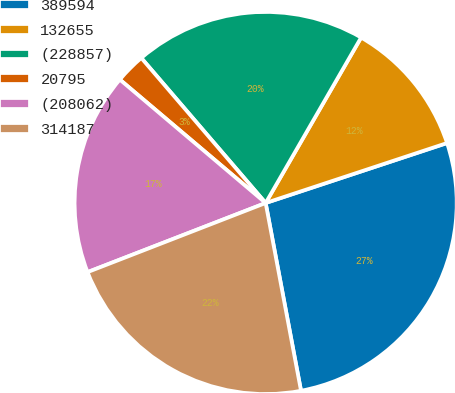<chart> <loc_0><loc_0><loc_500><loc_500><pie_chart><fcel>389594<fcel>132655<fcel>(228857)<fcel>20795<fcel>(208062)<fcel>314187<nl><fcel>27.12%<fcel>11.59%<fcel>19.61%<fcel>2.54%<fcel>17.07%<fcel>22.07%<nl></chart> 